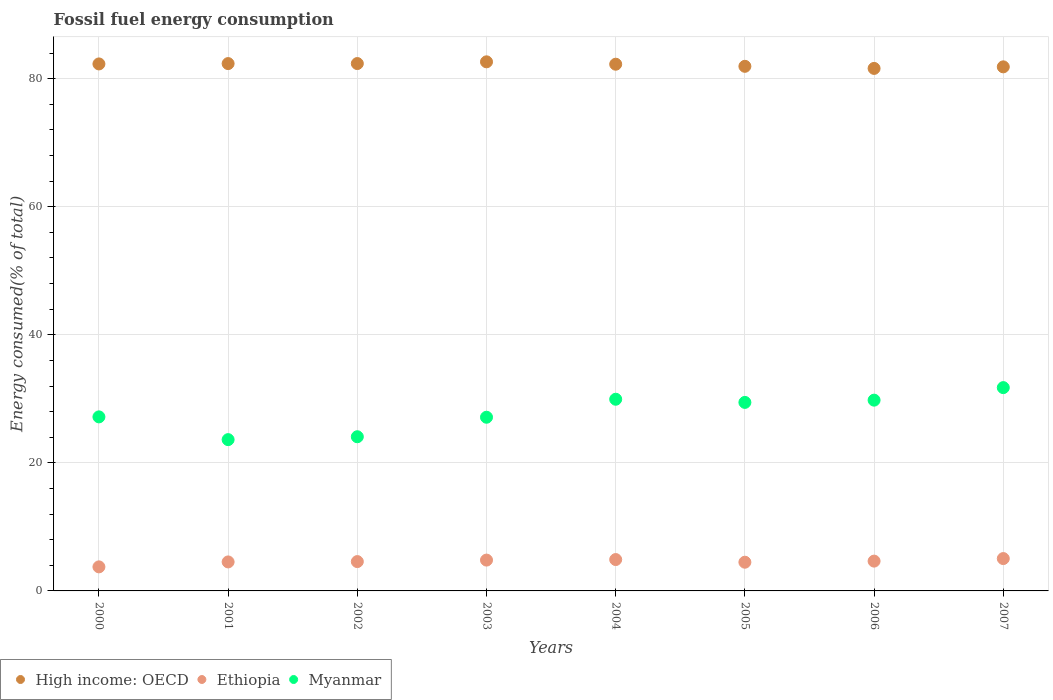What is the percentage of energy consumed in Myanmar in 2007?
Give a very brief answer. 31.75. Across all years, what is the maximum percentage of energy consumed in High income: OECD?
Your answer should be very brief. 82.64. Across all years, what is the minimum percentage of energy consumed in Ethiopia?
Your answer should be very brief. 3.76. In which year was the percentage of energy consumed in Myanmar maximum?
Your answer should be very brief. 2007. In which year was the percentage of energy consumed in High income: OECD minimum?
Your response must be concise. 2006. What is the total percentage of energy consumed in High income: OECD in the graph?
Your response must be concise. 657.33. What is the difference between the percentage of energy consumed in Myanmar in 2006 and that in 2007?
Give a very brief answer. -1.96. What is the difference between the percentage of energy consumed in Myanmar in 2004 and the percentage of energy consumed in Ethiopia in 2001?
Your answer should be compact. 25.41. What is the average percentage of energy consumed in Ethiopia per year?
Ensure brevity in your answer.  4.6. In the year 2005, what is the difference between the percentage of energy consumed in Ethiopia and percentage of energy consumed in Myanmar?
Offer a very short reply. -24.96. What is the ratio of the percentage of energy consumed in Ethiopia in 2000 to that in 2006?
Offer a very short reply. 0.81. Is the difference between the percentage of energy consumed in Ethiopia in 2001 and 2005 greater than the difference between the percentage of energy consumed in Myanmar in 2001 and 2005?
Make the answer very short. Yes. What is the difference between the highest and the second highest percentage of energy consumed in High income: OECD?
Provide a short and direct response. 0.27. What is the difference between the highest and the lowest percentage of energy consumed in Myanmar?
Your answer should be compact. 8.12. In how many years, is the percentage of energy consumed in Ethiopia greater than the average percentage of energy consumed in Ethiopia taken over all years?
Ensure brevity in your answer.  4. Is the sum of the percentage of energy consumed in Ethiopia in 2003 and 2007 greater than the maximum percentage of energy consumed in High income: OECD across all years?
Make the answer very short. No. Is it the case that in every year, the sum of the percentage of energy consumed in Myanmar and percentage of energy consumed in High income: OECD  is greater than the percentage of energy consumed in Ethiopia?
Make the answer very short. Yes. Is the percentage of energy consumed in High income: OECD strictly greater than the percentage of energy consumed in Ethiopia over the years?
Your answer should be compact. Yes. How many dotlines are there?
Make the answer very short. 3. What is the difference between two consecutive major ticks on the Y-axis?
Keep it short and to the point. 20. Are the values on the major ticks of Y-axis written in scientific E-notation?
Offer a terse response. No. How are the legend labels stacked?
Give a very brief answer. Horizontal. What is the title of the graph?
Your answer should be compact. Fossil fuel energy consumption. Does "Cabo Verde" appear as one of the legend labels in the graph?
Ensure brevity in your answer.  No. What is the label or title of the X-axis?
Keep it short and to the point. Years. What is the label or title of the Y-axis?
Keep it short and to the point. Energy consumed(% of total). What is the Energy consumed(% of total) in High income: OECD in 2000?
Offer a very short reply. 82.31. What is the Energy consumed(% of total) in Ethiopia in 2000?
Give a very brief answer. 3.76. What is the Energy consumed(% of total) of Myanmar in 2000?
Your answer should be compact. 27.18. What is the Energy consumed(% of total) of High income: OECD in 2001?
Your response must be concise. 82.36. What is the Energy consumed(% of total) in Ethiopia in 2001?
Your answer should be very brief. 4.53. What is the Energy consumed(% of total) in Myanmar in 2001?
Provide a succinct answer. 23.63. What is the Energy consumed(% of total) in High income: OECD in 2002?
Ensure brevity in your answer.  82.37. What is the Energy consumed(% of total) of Ethiopia in 2002?
Make the answer very short. 4.58. What is the Energy consumed(% of total) in Myanmar in 2002?
Keep it short and to the point. 24.08. What is the Energy consumed(% of total) of High income: OECD in 2003?
Provide a short and direct response. 82.64. What is the Energy consumed(% of total) of Ethiopia in 2003?
Make the answer very short. 4.82. What is the Energy consumed(% of total) of Myanmar in 2003?
Keep it short and to the point. 27.13. What is the Energy consumed(% of total) in High income: OECD in 2004?
Make the answer very short. 82.26. What is the Energy consumed(% of total) in Ethiopia in 2004?
Offer a terse response. 4.9. What is the Energy consumed(% of total) in Myanmar in 2004?
Offer a terse response. 29.94. What is the Energy consumed(% of total) in High income: OECD in 2005?
Keep it short and to the point. 81.94. What is the Energy consumed(% of total) of Ethiopia in 2005?
Offer a very short reply. 4.48. What is the Energy consumed(% of total) of Myanmar in 2005?
Make the answer very short. 29.44. What is the Energy consumed(% of total) in High income: OECD in 2006?
Your response must be concise. 81.61. What is the Energy consumed(% of total) in Ethiopia in 2006?
Keep it short and to the point. 4.66. What is the Energy consumed(% of total) of Myanmar in 2006?
Keep it short and to the point. 29.8. What is the Energy consumed(% of total) in High income: OECD in 2007?
Make the answer very short. 81.85. What is the Energy consumed(% of total) of Ethiopia in 2007?
Provide a succinct answer. 5.05. What is the Energy consumed(% of total) of Myanmar in 2007?
Your answer should be very brief. 31.75. Across all years, what is the maximum Energy consumed(% of total) in High income: OECD?
Your answer should be compact. 82.64. Across all years, what is the maximum Energy consumed(% of total) in Ethiopia?
Offer a terse response. 5.05. Across all years, what is the maximum Energy consumed(% of total) in Myanmar?
Provide a succinct answer. 31.75. Across all years, what is the minimum Energy consumed(% of total) of High income: OECD?
Provide a succinct answer. 81.61. Across all years, what is the minimum Energy consumed(% of total) in Ethiopia?
Offer a very short reply. 3.76. Across all years, what is the minimum Energy consumed(% of total) in Myanmar?
Your response must be concise. 23.63. What is the total Energy consumed(% of total) in High income: OECD in the graph?
Offer a terse response. 657.33. What is the total Energy consumed(% of total) of Ethiopia in the graph?
Provide a short and direct response. 36.77. What is the total Energy consumed(% of total) in Myanmar in the graph?
Provide a succinct answer. 222.95. What is the difference between the Energy consumed(% of total) in High income: OECD in 2000 and that in 2001?
Your answer should be very brief. -0.05. What is the difference between the Energy consumed(% of total) of Ethiopia in 2000 and that in 2001?
Provide a short and direct response. -0.77. What is the difference between the Energy consumed(% of total) of Myanmar in 2000 and that in 2001?
Make the answer very short. 3.55. What is the difference between the Energy consumed(% of total) in High income: OECD in 2000 and that in 2002?
Your response must be concise. -0.06. What is the difference between the Energy consumed(% of total) of Ethiopia in 2000 and that in 2002?
Offer a very short reply. -0.83. What is the difference between the Energy consumed(% of total) of Myanmar in 2000 and that in 2002?
Offer a very short reply. 3.1. What is the difference between the Energy consumed(% of total) in High income: OECD in 2000 and that in 2003?
Your response must be concise. -0.33. What is the difference between the Energy consumed(% of total) in Ethiopia in 2000 and that in 2003?
Keep it short and to the point. -1.06. What is the difference between the Energy consumed(% of total) in Myanmar in 2000 and that in 2003?
Your answer should be very brief. 0.06. What is the difference between the Energy consumed(% of total) in High income: OECD in 2000 and that in 2004?
Your response must be concise. 0.04. What is the difference between the Energy consumed(% of total) of Ethiopia in 2000 and that in 2004?
Keep it short and to the point. -1.14. What is the difference between the Energy consumed(% of total) of Myanmar in 2000 and that in 2004?
Your answer should be very brief. -2.76. What is the difference between the Energy consumed(% of total) in High income: OECD in 2000 and that in 2005?
Your answer should be compact. 0.37. What is the difference between the Energy consumed(% of total) of Ethiopia in 2000 and that in 2005?
Give a very brief answer. -0.73. What is the difference between the Energy consumed(% of total) of Myanmar in 2000 and that in 2005?
Your answer should be compact. -2.26. What is the difference between the Energy consumed(% of total) in High income: OECD in 2000 and that in 2006?
Give a very brief answer. 0.7. What is the difference between the Energy consumed(% of total) in Ethiopia in 2000 and that in 2006?
Provide a short and direct response. -0.9. What is the difference between the Energy consumed(% of total) of Myanmar in 2000 and that in 2006?
Offer a very short reply. -2.61. What is the difference between the Energy consumed(% of total) in High income: OECD in 2000 and that in 2007?
Give a very brief answer. 0.46. What is the difference between the Energy consumed(% of total) of Ethiopia in 2000 and that in 2007?
Provide a short and direct response. -1.3. What is the difference between the Energy consumed(% of total) in Myanmar in 2000 and that in 2007?
Provide a succinct answer. -4.57. What is the difference between the Energy consumed(% of total) in High income: OECD in 2001 and that in 2002?
Offer a terse response. -0. What is the difference between the Energy consumed(% of total) in Ethiopia in 2001 and that in 2002?
Provide a short and direct response. -0.05. What is the difference between the Energy consumed(% of total) in Myanmar in 2001 and that in 2002?
Ensure brevity in your answer.  -0.45. What is the difference between the Energy consumed(% of total) of High income: OECD in 2001 and that in 2003?
Offer a terse response. -0.28. What is the difference between the Energy consumed(% of total) of Ethiopia in 2001 and that in 2003?
Your response must be concise. -0.29. What is the difference between the Energy consumed(% of total) of Myanmar in 2001 and that in 2003?
Offer a very short reply. -3.5. What is the difference between the Energy consumed(% of total) in High income: OECD in 2001 and that in 2004?
Give a very brief answer. 0.1. What is the difference between the Energy consumed(% of total) in Ethiopia in 2001 and that in 2004?
Your answer should be compact. -0.37. What is the difference between the Energy consumed(% of total) of Myanmar in 2001 and that in 2004?
Keep it short and to the point. -6.31. What is the difference between the Energy consumed(% of total) in High income: OECD in 2001 and that in 2005?
Give a very brief answer. 0.43. What is the difference between the Energy consumed(% of total) of Ethiopia in 2001 and that in 2005?
Provide a short and direct response. 0.05. What is the difference between the Energy consumed(% of total) in Myanmar in 2001 and that in 2005?
Ensure brevity in your answer.  -5.81. What is the difference between the Energy consumed(% of total) in High income: OECD in 2001 and that in 2006?
Make the answer very short. 0.75. What is the difference between the Energy consumed(% of total) in Ethiopia in 2001 and that in 2006?
Your answer should be very brief. -0.13. What is the difference between the Energy consumed(% of total) of Myanmar in 2001 and that in 2006?
Your answer should be compact. -6.17. What is the difference between the Energy consumed(% of total) of High income: OECD in 2001 and that in 2007?
Your response must be concise. 0.51. What is the difference between the Energy consumed(% of total) in Ethiopia in 2001 and that in 2007?
Give a very brief answer. -0.52. What is the difference between the Energy consumed(% of total) in Myanmar in 2001 and that in 2007?
Offer a very short reply. -8.12. What is the difference between the Energy consumed(% of total) in High income: OECD in 2002 and that in 2003?
Keep it short and to the point. -0.27. What is the difference between the Energy consumed(% of total) of Ethiopia in 2002 and that in 2003?
Make the answer very short. -0.23. What is the difference between the Energy consumed(% of total) of Myanmar in 2002 and that in 2003?
Keep it short and to the point. -3.05. What is the difference between the Energy consumed(% of total) in High income: OECD in 2002 and that in 2004?
Offer a terse response. 0.1. What is the difference between the Energy consumed(% of total) of Ethiopia in 2002 and that in 2004?
Keep it short and to the point. -0.32. What is the difference between the Energy consumed(% of total) of Myanmar in 2002 and that in 2004?
Give a very brief answer. -5.86. What is the difference between the Energy consumed(% of total) of High income: OECD in 2002 and that in 2005?
Ensure brevity in your answer.  0.43. What is the difference between the Energy consumed(% of total) of Ethiopia in 2002 and that in 2005?
Make the answer very short. 0.1. What is the difference between the Energy consumed(% of total) of Myanmar in 2002 and that in 2005?
Provide a short and direct response. -5.36. What is the difference between the Energy consumed(% of total) of High income: OECD in 2002 and that in 2006?
Your response must be concise. 0.76. What is the difference between the Energy consumed(% of total) in Ethiopia in 2002 and that in 2006?
Your answer should be compact. -0.07. What is the difference between the Energy consumed(% of total) of Myanmar in 2002 and that in 2006?
Make the answer very short. -5.72. What is the difference between the Energy consumed(% of total) in High income: OECD in 2002 and that in 2007?
Your answer should be compact. 0.51. What is the difference between the Energy consumed(% of total) in Ethiopia in 2002 and that in 2007?
Ensure brevity in your answer.  -0.47. What is the difference between the Energy consumed(% of total) in Myanmar in 2002 and that in 2007?
Keep it short and to the point. -7.67. What is the difference between the Energy consumed(% of total) of High income: OECD in 2003 and that in 2004?
Make the answer very short. 0.37. What is the difference between the Energy consumed(% of total) of Ethiopia in 2003 and that in 2004?
Offer a very short reply. -0.08. What is the difference between the Energy consumed(% of total) in Myanmar in 2003 and that in 2004?
Your answer should be compact. -2.81. What is the difference between the Energy consumed(% of total) in High income: OECD in 2003 and that in 2005?
Your answer should be very brief. 0.7. What is the difference between the Energy consumed(% of total) in Ethiopia in 2003 and that in 2005?
Your answer should be very brief. 0.33. What is the difference between the Energy consumed(% of total) of Myanmar in 2003 and that in 2005?
Provide a short and direct response. -2.32. What is the difference between the Energy consumed(% of total) in High income: OECD in 2003 and that in 2006?
Make the answer very short. 1.03. What is the difference between the Energy consumed(% of total) of Ethiopia in 2003 and that in 2006?
Offer a terse response. 0.16. What is the difference between the Energy consumed(% of total) of Myanmar in 2003 and that in 2006?
Offer a very short reply. -2.67. What is the difference between the Energy consumed(% of total) of High income: OECD in 2003 and that in 2007?
Provide a short and direct response. 0.78. What is the difference between the Energy consumed(% of total) in Ethiopia in 2003 and that in 2007?
Provide a short and direct response. -0.24. What is the difference between the Energy consumed(% of total) of Myanmar in 2003 and that in 2007?
Make the answer very short. -4.63. What is the difference between the Energy consumed(% of total) in High income: OECD in 2004 and that in 2005?
Keep it short and to the point. 0.33. What is the difference between the Energy consumed(% of total) of Ethiopia in 2004 and that in 2005?
Make the answer very short. 0.42. What is the difference between the Energy consumed(% of total) of Myanmar in 2004 and that in 2005?
Provide a short and direct response. 0.49. What is the difference between the Energy consumed(% of total) in High income: OECD in 2004 and that in 2006?
Offer a very short reply. 0.66. What is the difference between the Energy consumed(% of total) in Ethiopia in 2004 and that in 2006?
Provide a short and direct response. 0.24. What is the difference between the Energy consumed(% of total) in Myanmar in 2004 and that in 2006?
Make the answer very short. 0.14. What is the difference between the Energy consumed(% of total) of High income: OECD in 2004 and that in 2007?
Your answer should be very brief. 0.41. What is the difference between the Energy consumed(% of total) in Ethiopia in 2004 and that in 2007?
Your answer should be very brief. -0.15. What is the difference between the Energy consumed(% of total) in Myanmar in 2004 and that in 2007?
Your answer should be very brief. -1.81. What is the difference between the Energy consumed(% of total) in High income: OECD in 2005 and that in 2006?
Offer a terse response. 0.33. What is the difference between the Energy consumed(% of total) of Ethiopia in 2005 and that in 2006?
Ensure brevity in your answer.  -0.17. What is the difference between the Energy consumed(% of total) of Myanmar in 2005 and that in 2006?
Your answer should be very brief. -0.35. What is the difference between the Energy consumed(% of total) in High income: OECD in 2005 and that in 2007?
Your answer should be compact. 0.08. What is the difference between the Energy consumed(% of total) of Ethiopia in 2005 and that in 2007?
Your response must be concise. -0.57. What is the difference between the Energy consumed(% of total) in Myanmar in 2005 and that in 2007?
Your answer should be very brief. -2.31. What is the difference between the Energy consumed(% of total) in High income: OECD in 2006 and that in 2007?
Your answer should be compact. -0.24. What is the difference between the Energy consumed(% of total) of Ethiopia in 2006 and that in 2007?
Ensure brevity in your answer.  -0.4. What is the difference between the Energy consumed(% of total) in Myanmar in 2006 and that in 2007?
Make the answer very short. -1.96. What is the difference between the Energy consumed(% of total) of High income: OECD in 2000 and the Energy consumed(% of total) of Ethiopia in 2001?
Ensure brevity in your answer.  77.78. What is the difference between the Energy consumed(% of total) of High income: OECD in 2000 and the Energy consumed(% of total) of Myanmar in 2001?
Keep it short and to the point. 58.68. What is the difference between the Energy consumed(% of total) in Ethiopia in 2000 and the Energy consumed(% of total) in Myanmar in 2001?
Your answer should be very brief. -19.87. What is the difference between the Energy consumed(% of total) of High income: OECD in 2000 and the Energy consumed(% of total) of Ethiopia in 2002?
Provide a short and direct response. 77.73. What is the difference between the Energy consumed(% of total) of High income: OECD in 2000 and the Energy consumed(% of total) of Myanmar in 2002?
Ensure brevity in your answer.  58.23. What is the difference between the Energy consumed(% of total) of Ethiopia in 2000 and the Energy consumed(% of total) of Myanmar in 2002?
Provide a short and direct response. -20.32. What is the difference between the Energy consumed(% of total) in High income: OECD in 2000 and the Energy consumed(% of total) in Ethiopia in 2003?
Ensure brevity in your answer.  77.49. What is the difference between the Energy consumed(% of total) of High income: OECD in 2000 and the Energy consumed(% of total) of Myanmar in 2003?
Provide a succinct answer. 55.18. What is the difference between the Energy consumed(% of total) of Ethiopia in 2000 and the Energy consumed(% of total) of Myanmar in 2003?
Provide a short and direct response. -23.37. What is the difference between the Energy consumed(% of total) in High income: OECD in 2000 and the Energy consumed(% of total) in Ethiopia in 2004?
Give a very brief answer. 77.41. What is the difference between the Energy consumed(% of total) of High income: OECD in 2000 and the Energy consumed(% of total) of Myanmar in 2004?
Provide a short and direct response. 52.37. What is the difference between the Energy consumed(% of total) in Ethiopia in 2000 and the Energy consumed(% of total) in Myanmar in 2004?
Give a very brief answer. -26.18. What is the difference between the Energy consumed(% of total) in High income: OECD in 2000 and the Energy consumed(% of total) in Ethiopia in 2005?
Your answer should be very brief. 77.82. What is the difference between the Energy consumed(% of total) in High income: OECD in 2000 and the Energy consumed(% of total) in Myanmar in 2005?
Provide a short and direct response. 52.87. What is the difference between the Energy consumed(% of total) of Ethiopia in 2000 and the Energy consumed(% of total) of Myanmar in 2005?
Make the answer very short. -25.69. What is the difference between the Energy consumed(% of total) in High income: OECD in 2000 and the Energy consumed(% of total) in Ethiopia in 2006?
Your answer should be compact. 77.65. What is the difference between the Energy consumed(% of total) in High income: OECD in 2000 and the Energy consumed(% of total) in Myanmar in 2006?
Provide a succinct answer. 52.51. What is the difference between the Energy consumed(% of total) in Ethiopia in 2000 and the Energy consumed(% of total) in Myanmar in 2006?
Provide a succinct answer. -26.04. What is the difference between the Energy consumed(% of total) of High income: OECD in 2000 and the Energy consumed(% of total) of Ethiopia in 2007?
Offer a very short reply. 77.25. What is the difference between the Energy consumed(% of total) of High income: OECD in 2000 and the Energy consumed(% of total) of Myanmar in 2007?
Your answer should be compact. 50.56. What is the difference between the Energy consumed(% of total) of Ethiopia in 2000 and the Energy consumed(% of total) of Myanmar in 2007?
Offer a very short reply. -28. What is the difference between the Energy consumed(% of total) of High income: OECD in 2001 and the Energy consumed(% of total) of Ethiopia in 2002?
Your response must be concise. 77.78. What is the difference between the Energy consumed(% of total) of High income: OECD in 2001 and the Energy consumed(% of total) of Myanmar in 2002?
Ensure brevity in your answer.  58.28. What is the difference between the Energy consumed(% of total) of Ethiopia in 2001 and the Energy consumed(% of total) of Myanmar in 2002?
Give a very brief answer. -19.55. What is the difference between the Energy consumed(% of total) of High income: OECD in 2001 and the Energy consumed(% of total) of Ethiopia in 2003?
Offer a terse response. 77.55. What is the difference between the Energy consumed(% of total) in High income: OECD in 2001 and the Energy consumed(% of total) in Myanmar in 2003?
Make the answer very short. 55.23. What is the difference between the Energy consumed(% of total) in Ethiopia in 2001 and the Energy consumed(% of total) in Myanmar in 2003?
Your answer should be compact. -22.6. What is the difference between the Energy consumed(% of total) in High income: OECD in 2001 and the Energy consumed(% of total) in Ethiopia in 2004?
Provide a succinct answer. 77.46. What is the difference between the Energy consumed(% of total) of High income: OECD in 2001 and the Energy consumed(% of total) of Myanmar in 2004?
Your answer should be very brief. 52.42. What is the difference between the Energy consumed(% of total) of Ethiopia in 2001 and the Energy consumed(% of total) of Myanmar in 2004?
Your answer should be compact. -25.41. What is the difference between the Energy consumed(% of total) of High income: OECD in 2001 and the Energy consumed(% of total) of Ethiopia in 2005?
Offer a terse response. 77.88. What is the difference between the Energy consumed(% of total) of High income: OECD in 2001 and the Energy consumed(% of total) of Myanmar in 2005?
Provide a succinct answer. 52.92. What is the difference between the Energy consumed(% of total) in Ethiopia in 2001 and the Energy consumed(% of total) in Myanmar in 2005?
Your answer should be compact. -24.91. What is the difference between the Energy consumed(% of total) in High income: OECD in 2001 and the Energy consumed(% of total) in Ethiopia in 2006?
Keep it short and to the point. 77.71. What is the difference between the Energy consumed(% of total) of High income: OECD in 2001 and the Energy consumed(% of total) of Myanmar in 2006?
Offer a very short reply. 52.57. What is the difference between the Energy consumed(% of total) of Ethiopia in 2001 and the Energy consumed(% of total) of Myanmar in 2006?
Your response must be concise. -25.27. What is the difference between the Energy consumed(% of total) in High income: OECD in 2001 and the Energy consumed(% of total) in Ethiopia in 2007?
Your answer should be very brief. 77.31. What is the difference between the Energy consumed(% of total) of High income: OECD in 2001 and the Energy consumed(% of total) of Myanmar in 2007?
Your response must be concise. 50.61. What is the difference between the Energy consumed(% of total) in Ethiopia in 2001 and the Energy consumed(% of total) in Myanmar in 2007?
Provide a short and direct response. -27.22. What is the difference between the Energy consumed(% of total) in High income: OECD in 2002 and the Energy consumed(% of total) in Ethiopia in 2003?
Offer a very short reply. 77.55. What is the difference between the Energy consumed(% of total) in High income: OECD in 2002 and the Energy consumed(% of total) in Myanmar in 2003?
Provide a short and direct response. 55.24. What is the difference between the Energy consumed(% of total) in Ethiopia in 2002 and the Energy consumed(% of total) in Myanmar in 2003?
Your answer should be very brief. -22.55. What is the difference between the Energy consumed(% of total) of High income: OECD in 2002 and the Energy consumed(% of total) of Ethiopia in 2004?
Provide a succinct answer. 77.47. What is the difference between the Energy consumed(% of total) in High income: OECD in 2002 and the Energy consumed(% of total) in Myanmar in 2004?
Offer a terse response. 52.43. What is the difference between the Energy consumed(% of total) in Ethiopia in 2002 and the Energy consumed(% of total) in Myanmar in 2004?
Your answer should be compact. -25.36. What is the difference between the Energy consumed(% of total) in High income: OECD in 2002 and the Energy consumed(% of total) in Ethiopia in 2005?
Make the answer very short. 77.88. What is the difference between the Energy consumed(% of total) of High income: OECD in 2002 and the Energy consumed(% of total) of Myanmar in 2005?
Provide a succinct answer. 52.92. What is the difference between the Energy consumed(% of total) of Ethiopia in 2002 and the Energy consumed(% of total) of Myanmar in 2005?
Make the answer very short. -24.86. What is the difference between the Energy consumed(% of total) in High income: OECD in 2002 and the Energy consumed(% of total) in Ethiopia in 2006?
Your answer should be very brief. 77.71. What is the difference between the Energy consumed(% of total) in High income: OECD in 2002 and the Energy consumed(% of total) in Myanmar in 2006?
Provide a short and direct response. 52.57. What is the difference between the Energy consumed(% of total) in Ethiopia in 2002 and the Energy consumed(% of total) in Myanmar in 2006?
Make the answer very short. -25.21. What is the difference between the Energy consumed(% of total) of High income: OECD in 2002 and the Energy consumed(% of total) of Ethiopia in 2007?
Provide a succinct answer. 77.31. What is the difference between the Energy consumed(% of total) in High income: OECD in 2002 and the Energy consumed(% of total) in Myanmar in 2007?
Provide a succinct answer. 50.61. What is the difference between the Energy consumed(% of total) of Ethiopia in 2002 and the Energy consumed(% of total) of Myanmar in 2007?
Give a very brief answer. -27.17. What is the difference between the Energy consumed(% of total) in High income: OECD in 2003 and the Energy consumed(% of total) in Ethiopia in 2004?
Make the answer very short. 77.74. What is the difference between the Energy consumed(% of total) of High income: OECD in 2003 and the Energy consumed(% of total) of Myanmar in 2004?
Your answer should be compact. 52.7. What is the difference between the Energy consumed(% of total) in Ethiopia in 2003 and the Energy consumed(% of total) in Myanmar in 2004?
Keep it short and to the point. -25.12. What is the difference between the Energy consumed(% of total) of High income: OECD in 2003 and the Energy consumed(% of total) of Ethiopia in 2005?
Ensure brevity in your answer.  78.15. What is the difference between the Energy consumed(% of total) in High income: OECD in 2003 and the Energy consumed(% of total) in Myanmar in 2005?
Provide a short and direct response. 53.19. What is the difference between the Energy consumed(% of total) in Ethiopia in 2003 and the Energy consumed(% of total) in Myanmar in 2005?
Your answer should be very brief. -24.63. What is the difference between the Energy consumed(% of total) of High income: OECD in 2003 and the Energy consumed(% of total) of Ethiopia in 2006?
Your answer should be compact. 77.98. What is the difference between the Energy consumed(% of total) of High income: OECD in 2003 and the Energy consumed(% of total) of Myanmar in 2006?
Offer a terse response. 52.84. What is the difference between the Energy consumed(% of total) in Ethiopia in 2003 and the Energy consumed(% of total) in Myanmar in 2006?
Keep it short and to the point. -24.98. What is the difference between the Energy consumed(% of total) of High income: OECD in 2003 and the Energy consumed(% of total) of Ethiopia in 2007?
Give a very brief answer. 77.58. What is the difference between the Energy consumed(% of total) in High income: OECD in 2003 and the Energy consumed(% of total) in Myanmar in 2007?
Ensure brevity in your answer.  50.88. What is the difference between the Energy consumed(% of total) of Ethiopia in 2003 and the Energy consumed(% of total) of Myanmar in 2007?
Your answer should be compact. -26.94. What is the difference between the Energy consumed(% of total) of High income: OECD in 2004 and the Energy consumed(% of total) of Ethiopia in 2005?
Offer a very short reply. 77.78. What is the difference between the Energy consumed(% of total) in High income: OECD in 2004 and the Energy consumed(% of total) in Myanmar in 2005?
Provide a short and direct response. 52.82. What is the difference between the Energy consumed(% of total) of Ethiopia in 2004 and the Energy consumed(% of total) of Myanmar in 2005?
Offer a very short reply. -24.54. What is the difference between the Energy consumed(% of total) in High income: OECD in 2004 and the Energy consumed(% of total) in Ethiopia in 2006?
Ensure brevity in your answer.  77.61. What is the difference between the Energy consumed(% of total) in High income: OECD in 2004 and the Energy consumed(% of total) in Myanmar in 2006?
Keep it short and to the point. 52.47. What is the difference between the Energy consumed(% of total) in Ethiopia in 2004 and the Energy consumed(% of total) in Myanmar in 2006?
Your response must be concise. -24.9. What is the difference between the Energy consumed(% of total) of High income: OECD in 2004 and the Energy consumed(% of total) of Ethiopia in 2007?
Your answer should be very brief. 77.21. What is the difference between the Energy consumed(% of total) of High income: OECD in 2004 and the Energy consumed(% of total) of Myanmar in 2007?
Provide a short and direct response. 50.51. What is the difference between the Energy consumed(% of total) of Ethiopia in 2004 and the Energy consumed(% of total) of Myanmar in 2007?
Your response must be concise. -26.85. What is the difference between the Energy consumed(% of total) in High income: OECD in 2005 and the Energy consumed(% of total) in Ethiopia in 2006?
Provide a short and direct response. 77.28. What is the difference between the Energy consumed(% of total) in High income: OECD in 2005 and the Energy consumed(% of total) in Myanmar in 2006?
Make the answer very short. 52.14. What is the difference between the Energy consumed(% of total) of Ethiopia in 2005 and the Energy consumed(% of total) of Myanmar in 2006?
Keep it short and to the point. -25.31. What is the difference between the Energy consumed(% of total) in High income: OECD in 2005 and the Energy consumed(% of total) in Ethiopia in 2007?
Provide a short and direct response. 76.88. What is the difference between the Energy consumed(% of total) of High income: OECD in 2005 and the Energy consumed(% of total) of Myanmar in 2007?
Your answer should be compact. 50.18. What is the difference between the Energy consumed(% of total) in Ethiopia in 2005 and the Energy consumed(% of total) in Myanmar in 2007?
Offer a terse response. -27.27. What is the difference between the Energy consumed(% of total) of High income: OECD in 2006 and the Energy consumed(% of total) of Ethiopia in 2007?
Keep it short and to the point. 76.55. What is the difference between the Energy consumed(% of total) in High income: OECD in 2006 and the Energy consumed(% of total) in Myanmar in 2007?
Your answer should be compact. 49.86. What is the difference between the Energy consumed(% of total) in Ethiopia in 2006 and the Energy consumed(% of total) in Myanmar in 2007?
Your answer should be compact. -27.1. What is the average Energy consumed(% of total) of High income: OECD per year?
Your response must be concise. 82.17. What is the average Energy consumed(% of total) in Ethiopia per year?
Your response must be concise. 4.6. What is the average Energy consumed(% of total) of Myanmar per year?
Your answer should be very brief. 27.87. In the year 2000, what is the difference between the Energy consumed(% of total) of High income: OECD and Energy consumed(% of total) of Ethiopia?
Provide a succinct answer. 78.55. In the year 2000, what is the difference between the Energy consumed(% of total) in High income: OECD and Energy consumed(% of total) in Myanmar?
Offer a very short reply. 55.13. In the year 2000, what is the difference between the Energy consumed(% of total) of Ethiopia and Energy consumed(% of total) of Myanmar?
Give a very brief answer. -23.43. In the year 2001, what is the difference between the Energy consumed(% of total) of High income: OECD and Energy consumed(% of total) of Ethiopia?
Ensure brevity in your answer.  77.83. In the year 2001, what is the difference between the Energy consumed(% of total) in High income: OECD and Energy consumed(% of total) in Myanmar?
Your answer should be very brief. 58.73. In the year 2001, what is the difference between the Energy consumed(% of total) in Ethiopia and Energy consumed(% of total) in Myanmar?
Your response must be concise. -19.1. In the year 2002, what is the difference between the Energy consumed(% of total) in High income: OECD and Energy consumed(% of total) in Ethiopia?
Keep it short and to the point. 77.78. In the year 2002, what is the difference between the Energy consumed(% of total) in High income: OECD and Energy consumed(% of total) in Myanmar?
Your answer should be very brief. 58.29. In the year 2002, what is the difference between the Energy consumed(% of total) of Ethiopia and Energy consumed(% of total) of Myanmar?
Ensure brevity in your answer.  -19.5. In the year 2003, what is the difference between the Energy consumed(% of total) in High income: OECD and Energy consumed(% of total) in Ethiopia?
Provide a succinct answer. 77.82. In the year 2003, what is the difference between the Energy consumed(% of total) in High income: OECD and Energy consumed(% of total) in Myanmar?
Keep it short and to the point. 55.51. In the year 2003, what is the difference between the Energy consumed(% of total) in Ethiopia and Energy consumed(% of total) in Myanmar?
Offer a terse response. -22.31. In the year 2004, what is the difference between the Energy consumed(% of total) of High income: OECD and Energy consumed(% of total) of Ethiopia?
Keep it short and to the point. 77.36. In the year 2004, what is the difference between the Energy consumed(% of total) of High income: OECD and Energy consumed(% of total) of Myanmar?
Keep it short and to the point. 52.33. In the year 2004, what is the difference between the Energy consumed(% of total) of Ethiopia and Energy consumed(% of total) of Myanmar?
Your response must be concise. -25.04. In the year 2005, what is the difference between the Energy consumed(% of total) in High income: OECD and Energy consumed(% of total) in Ethiopia?
Provide a short and direct response. 77.45. In the year 2005, what is the difference between the Energy consumed(% of total) of High income: OECD and Energy consumed(% of total) of Myanmar?
Ensure brevity in your answer.  52.49. In the year 2005, what is the difference between the Energy consumed(% of total) in Ethiopia and Energy consumed(% of total) in Myanmar?
Keep it short and to the point. -24.96. In the year 2006, what is the difference between the Energy consumed(% of total) in High income: OECD and Energy consumed(% of total) in Ethiopia?
Make the answer very short. 76.95. In the year 2006, what is the difference between the Energy consumed(% of total) of High income: OECD and Energy consumed(% of total) of Myanmar?
Your answer should be compact. 51.81. In the year 2006, what is the difference between the Energy consumed(% of total) of Ethiopia and Energy consumed(% of total) of Myanmar?
Provide a short and direct response. -25.14. In the year 2007, what is the difference between the Energy consumed(% of total) in High income: OECD and Energy consumed(% of total) in Ethiopia?
Provide a succinct answer. 76.8. In the year 2007, what is the difference between the Energy consumed(% of total) in High income: OECD and Energy consumed(% of total) in Myanmar?
Ensure brevity in your answer.  50.1. In the year 2007, what is the difference between the Energy consumed(% of total) of Ethiopia and Energy consumed(% of total) of Myanmar?
Make the answer very short. -26.7. What is the ratio of the Energy consumed(% of total) in High income: OECD in 2000 to that in 2001?
Keep it short and to the point. 1. What is the ratio of the Energy consumed(% of total) of Ethiopia in 2000 to that in 2001?
Make the answer very short. 0.83. What is the ratio of the Energy consumed(% of total) of Myanmar in 2000 to that in 2001?
Your answer should be compact. 1.15. What is the ratio of the Energy consumed(% of total) in High income: OECD in 2000 to that in 2002?
Your answer should be compact. 1. What is the ratio of the Energy consumed(% of total) of Ethiopia in 2000 to that in 2002?
Provide a succinct answer. 0.82. What is the ratio of the Energy consumed(% of total) of Myanmar in 2000 to that in 2002?
Provide a short and direct response. 1.13. What is the ratio of the Energy consumed(% of total) in High income: OECD in 2000 to that in 2003?
Ensure brevity in your answer.  1. What is the ratio of the Energy consumed(% of total) of Ethiopia in 2000 to that in 2003?
Offer a very short reply. 0.78. What is the ratio of the Energy consumed(% of total) of Myanmar in 2000 to that in 2003?
Ensure brevity in your answer.  1. What is the ratio of the Energy consumed(% of total) of Ethiopia in 2000 to that in 2004?
Provide a short and direct response. 0.77. What is the ratio of the Energy consumed(% of total) of Myanmar in 2000 to that in 2004?
Your answer should be compact. 0.91. What is the ratio of the Energy consumed(% of total) of Ethiopia in 2000 to that in 2005?
Your response must be concise. 0.84. What is the ratio of the Energy consumed(% of total) in Myanmar in 2000 to that in 2005?
Your answer should be very brief. 0.92. What is the ratio of the Energy consumed(% of total) in High income: OECD in 2000 to that in 2006?
Provide a short and direct response. 1.01. What is the ratio of the Energy consumed(% of total) in Ethiopia in 2000 to that in 2006?
Make the answer very short. 0.81. What is the ratio of the Energy consumed(% of total) in Myanmar in 2000 to that in 2006?
Provide a short and direct response. 0.91. What is the ratio of the Energy consumed(% of total) in High income: OECD in 2000 to that in 2007?
Give a very brief answer. 1.01. What is the ratio of the Energy consumed(% of total) in Ethiopia in 2000 to that in 2007?
Your answer should be very brief. 0.74. What is the ratio of the Energy consumed(% of total) in Myanmar in 2000 to that in 2007?
Your answer should be compact. 0.86. What is the ratio of the Energy consumed(% of total) in High income: OECD in 2001 to that in 2002?
Keep it short and to the point. 1. What is the ratio of the Energy consumed(% of total) of Ethiopia in 2001 to that in 2002?
Your response must be concise. 0.99. What is the ratio of the Energy consumed(% of total) of Myanmar in 2001 to that in 2002?
Keep it short and to the point. 0.98. What is the ratio of the Energy consumed(% of total) in Ethiopia in 2001 to that in 2003?
Keep it short and to the point. 0.94. What is the ratio of the Energy consumed(% of total) in Myanmar in 2001 to that in 2003?
Keep it short and to the point. 0.87. What is the ratio of the Energy consumed(% of total) of High income: OECD in 2001 to that in 2004?
Your answer should be compact. 1. What is the ratio of the Energy consumed(% of total) in Ethiopia in 2001 to that in 2004?
Make the answer very short. 0.92. What is the ratio of the Energy consumed(% of total) of Myanmar in 2001 to that in 2004?
Offer a very short reply. 0.79. What is the ratio of the Energy consumed(% of total) of Myanmar in 2001 to that in 2005?
Offer a very short reply. 0.8. What is the ratio of the Energy consumed(% of total) in High income: OECD in 2001 to that in 2006?
Your response must be concise. 1.01. What is the ratio of the Energy consumed(% of total) in Ethiopia in 2001 to that in 2006?
Offer a terse response. 0.97. What is the ratio of the Energy consumed(% of total) in Myanmar in 2001 to that in 2006?
Provide a short and direct response. 0.79. What is the ratio of the Energy consumed(% of total) of High income: OECD in 2001 to that in 2007?
Provide a succinct answer. 1.01. What is the ratio of the Energy consumed(% of total) of Ethiopia in 2001 to that in 2007?
Give a very brief answer. 0.9. What is the ratio of the Energy consumed(% of total) in Myanmar in 2001 to that in 2007?
Keep it short and to the point. 0.74. What is the ratio of the Energy consumed(% of total) of High income: OECD in 2002 to that in 2003?
Your answer should be compact. 1. What is the ratio of the Energy consumed(% of total) in Ethiopia in 2002 to that in 2003?
Give a very brief answer. 0.95. What is the ratio of the Energy consumed(% of total) in Myanmar in 2002 to that in 2003?
Offer a terse response. 0.89. What is the ratio of the Energy consumed(% of total) in High income: OECD in 2002 to that in 2004?
Keep it short and to the point. 1. What is the ratio of the Energy consumed(% of total) in Ethiopia in 2002 to that in 2004?
Offer a terse response. 0.94. What is the ratio of the Energy consumed(% of total) in Myanmar in 2002 to that in 2004?
Provide a short and direct response. 0.8. What is the ratio of the Energy consumed(% of total) of High income: OECD in 2002 to that in 2005?
Give a very brief answer. 1.01. What is the ratio of the Energy consumed(% of total) in Ethiopia in 2002 to that in 2005?
Provide a short and direct response. 1.02. What is the ratio of the Energy consumed(% of total) in Myanmar in 2002 to that in 2005?
Keep it short and to the point. 0.82. What is the ratio of the Energy consumed(% of total) of High income: OECD in 2002 to that in 2006?
Keep it short and to the point. 1.01. What is the ratio of the Energy consumed(% of total) of Ethiopia in 2002 to that in 2006?
Provide a short and direct response. 0.98. What is the ratio of the Energy consumed(% of total) in Myanmar in 2002 to that in 2006?
Ensure brevity in your answer.  0.81. What is the ratio of the Energy consumed(% of total) of High income: OECD in 2002 to that in 2007?
Your answer should be compact. 1.01. What is the ratio of the Energy consumed(% of total) of Ethiopia in 2002 to that in 2007?
Provide a short and direct response. 0.91. What is the ratio of the Energy consumed(% of total) of Myanmar in 2002 to that in 2007?
Your response must be concise. 0.76. What is the ratio of the Energy consumed(% of total) of High income: OECD in 2003 to that in 2004?
Your answer should be compact. 1. What is the ratio of the Energy consumed(% of total) in Ethiopia in 2003 to that in 2004?
Offer a terse response. 0.98. What is the ratio of the Energy consumed(% of total) of Myanmar in 2003 to that in 2004?
Provide a short and direct response. 0.91. What is the ratio of the Energy consumed(% of total) in High income: OECD in 2003 to that in 2005?
Your response must be concise. 1.01. What is the ratio of the Energy consumed(% of total) of Ethiopia in 2003 to that in 2005?
Make the answer very short. 1.07. What is the ratio of the Energy consumed(% of total) of Myanmar in 2003 to that in 2005?
Make the answer very short. 0.92. What is the ratio of the Energy consumed(% of total) in High income: OECD in 2003 to that in 2006?
Ensure brevity in your answer.  1.01. What is the ratio of the Energy consumed(% of total) in Ethiopia in 2003 to that in 2006?
Offer a very short reply. 1.03. What is the ratio of the Energy consumed(% of total) of Myanmar in 2003 to that in 2006?
Give a very brief answer. 0.91. What is the ratio of the Energy consumed(% of total) of High income: OECD in 2003 to that in 2007?
Offer a very short reply. 1.01. What is the ratio of the Energy consumed(% of total) of Ethiopia in 2003 to that in 2007?
Provide a succinct answer. 0.95. What is the ratio of the Energy consumed(% of total) in Myanmar in 2003 to that in 2007?
Offer a terse response. 0.85. What is the ratio of the Energy consumed(% of total) of High income: OECD in 2004 to that in 2005?
Your answer should be very brief. 1. What is the ratio of the Energy consumed(% of total) of Ethiopia in 2004 to that in 2005?
Give a very brief answer. 1.09. What is the ratio of the Energy consumed(% of total) of Myanmar in 2004 to that in 2005?
Keep it short and to the point. 1.02. What is the ratio of the Energy consumed(% of total) of Ethiopia in 2004 to that in 2006?
Your answer should be very brief. 1.05. What is the ratio of the Energy consumed(% of total) in Myanmar in 2004 to that in 2006?
Your answer should be compact. 1. What is the ratio of the Energy consumed(% of total) of Ethiopia in 2004 to that in 2007?
Your answer should be very brief. 0.97. What is the ratio of the Energy consumed(% of total) of Myanmar in 2004 to that in 2007?
Offer a terse response. 0.94. What is the ratio of the Energy consumed(% of total) of High income: OECD in 2005 to that in 2006?
Offer a terse response. 1. What is the ratio of the Energy consumed(% of total) in Ethiopia in 2005 to that in 2006?
Your answer should be compact. 0.96. What is the ratio of the Energy consumed(% of total) of Myanmar in 2005 to that in 2006?
Offer a terse response. 0.99. What is the ratio of the Energy consumed(% of total) in Ethiopia in 2005 to that in 2007?
Provide a short and direct response. 0.89. What is the ratio of the Energy consumed(% of total) of Myanmar in 2005 to that in 2007?
Provide a short and direct response. 0.93. What is the ratio of the Energy consumed(% of total) of High income: OECD in 2006 to that in 2007?
Your response must be concise. 1. What is the ratio of the Energy consumed(% of total) in Ethiopia in 2006 to that in 2007?
Offer a very short reply. 0.92. What is the ratio of the Energy consumed(% of total) of Myanmar in 2006 to that in 2007?
Offer a terse response. 0.94. What is the difference between the highest and the second highest Energy consumed(% of total) in High income: OECD?
Ensure brevity in your answer.  0.27. What is the difference between the highest and the second highest Energy consumed(% of total) of Ethiopia?
Keep it short and to the point. 0.15. What is the difference between the highest and the second highest Energy consumed(% of total) of Myanmar?
Ensure brevity in your answer.  1.81. What is the difference between the highest and the lowest Energy consumed(% of total) in High income: OECD?
Provide a succinct answer. 1.03. What is the difference between the highest and the lowest Energy consumed(% of total) of Ethiopia?
Offer a terse response. 1.3. What is the difference between the highest and the lowest Energy consumed(% of total) of Myanmar?
Provide a succinct answer. 8.12. 